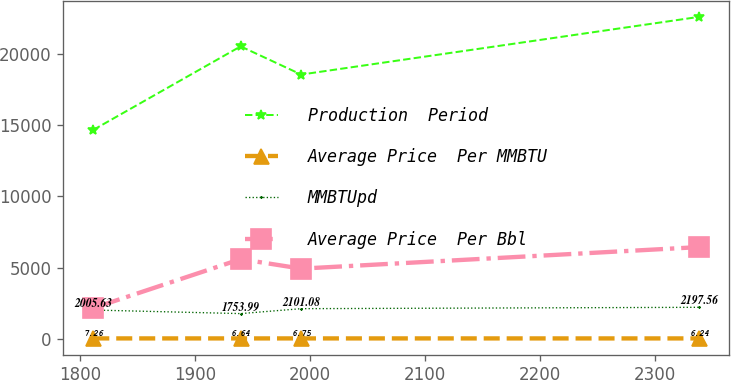Convert chart. <chart><loc_0><loc_0><loc_500><loc_500><line_chart><ecel><fcel>Production  Period<fcel>Average Price  Per MMBTU<fcel>MMBTUpd<fcel>Average Price  Per Bbl<nl><fcel>1811.25<fcel>14689.2<fcel>7.26<fcel>2005.63<fcel>2144.53<nl><fcel>1939.54<fcel>20571.6<fcel>6.64<fcel>1753.99<fcel>5589.59<nl><fcel>1992.28<fcel>18587.1<fcel>6.75<fcel>2101.08<fcel>4920.89<nl><fcel>2338.67<fcel>22649.2<fcel>6.24<fcel>2197.56<fcel>6437.54<nl></chart> 